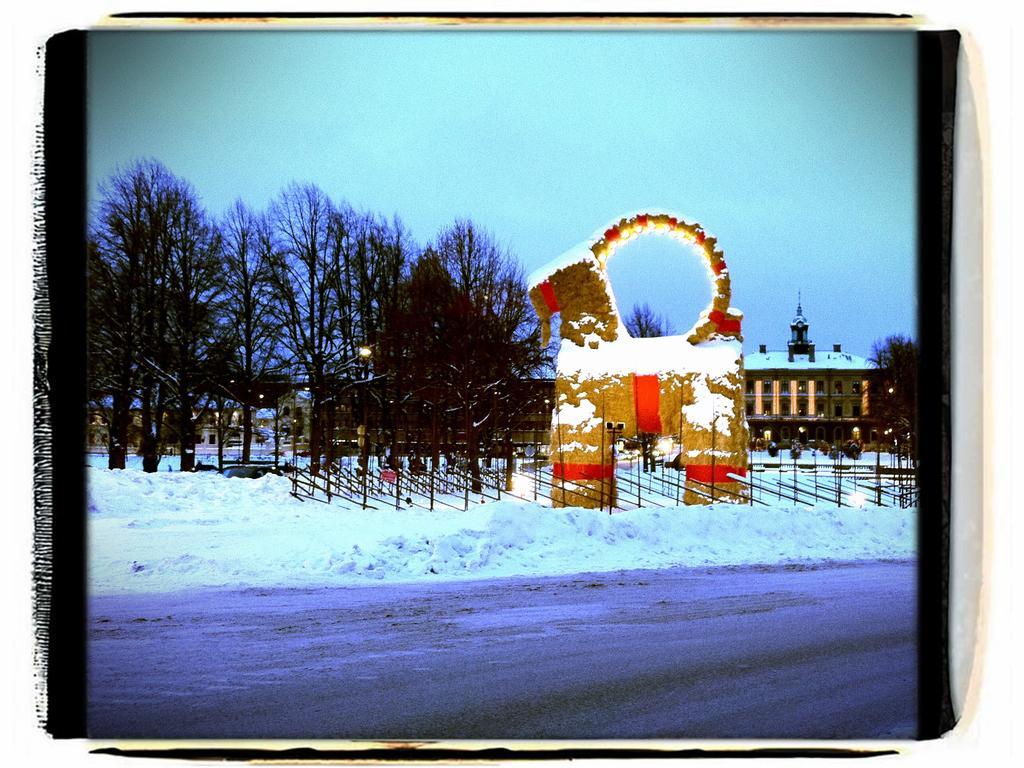Can you describe this image briefly? This image is an edited image. This image is taken outdoors. At the top of the image there is the sky. At the bottom of the image there is a ground. In the background there are a few houses and there are a few trees. In the middle of the image there is a fence and there are a few trees and there is a ground covered with snow. There is an artificial horse covered with snow. 